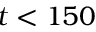Convert formula to latex. <formula><loc_0><loc_0><loc_500><loc_500>t < 1 5 0</formula> 